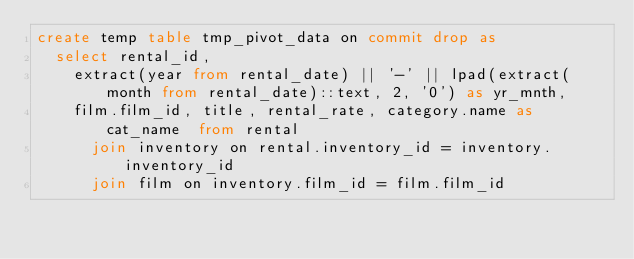<code> <loc_0><loc_0><loc_500><loc_500><_SQL_>create temp table tmp_pivot_data on commit drop as
  select rental_id, 
    extract(year from rental_date) || '-' || lpad(extract(month from rental_date)::text, 2, '0') as yr_mnth,
    film.film_id, title, rental_rate, category.name as cat_name  from rental
      join inventory on rental.inventory_id = inventory.inventory_id
      join film on inventory.film_id = film.film_id</code> 